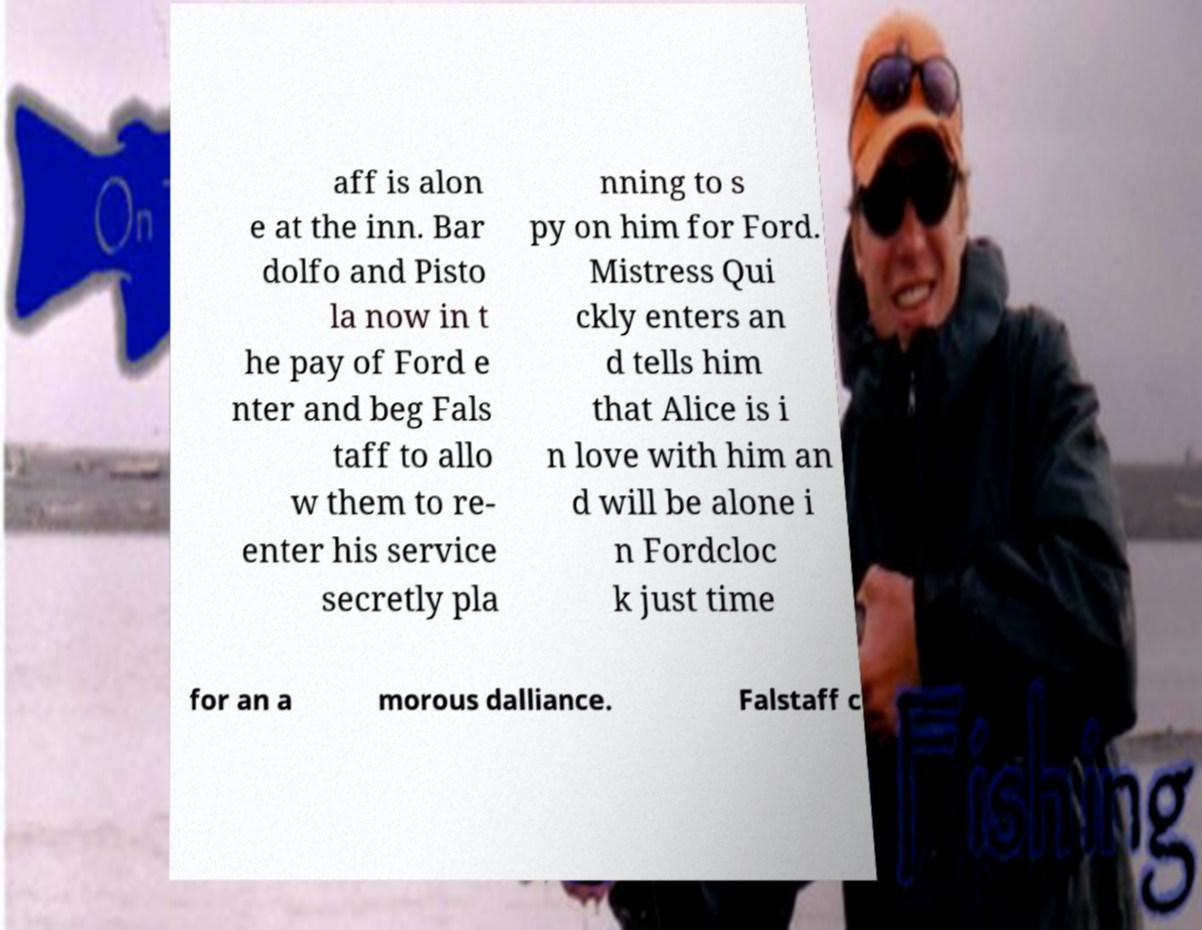Please identify and transcribe the text found in this image. aff is alon e at the inn. Bar dolfo and Pisto la now in t he pay of Ford e nter and beg Fals taff to allo w them to re- enter his service secretly pla nning to s py on him for Ford. Mistress Qui ckly enters an d tells him that Alice is i n love with him an d will be alone i n Fordcloc k just time for an a morous dalliance. Falstaff c 